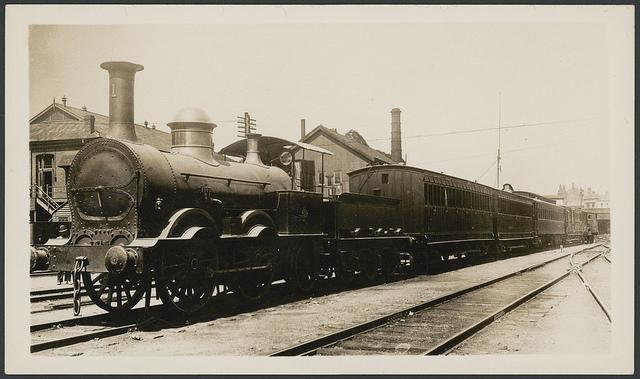Who is holding the umbrella?
Write a very short answer. No one. Is it a modern train?
Answer briefly. No. What is in the picture?
Write a very short answer. Train. How many trains are there?
Concise answer only. 1. Is there a building in the picture?
Write a very short answer. Yes. 